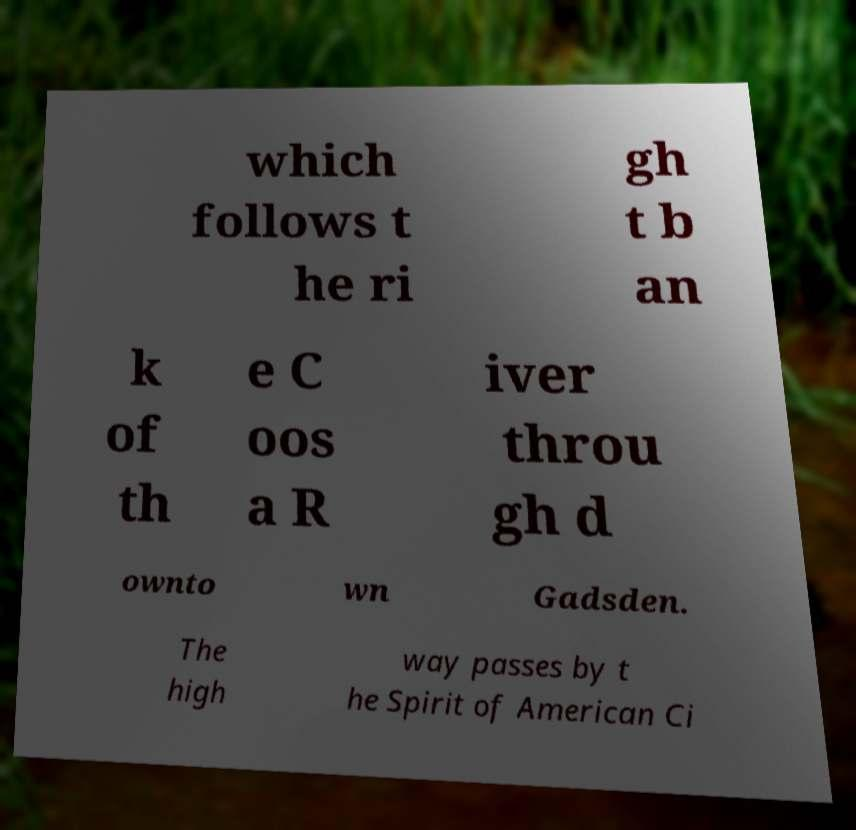There's text embedded in this image that I need extracted. Can you transcribe it verbatim? which follows t he ri gh t b an k of th e C oos a R iver throu gh d ownto wn Gadsden. The high way passes by t he Spirit of American Ci 